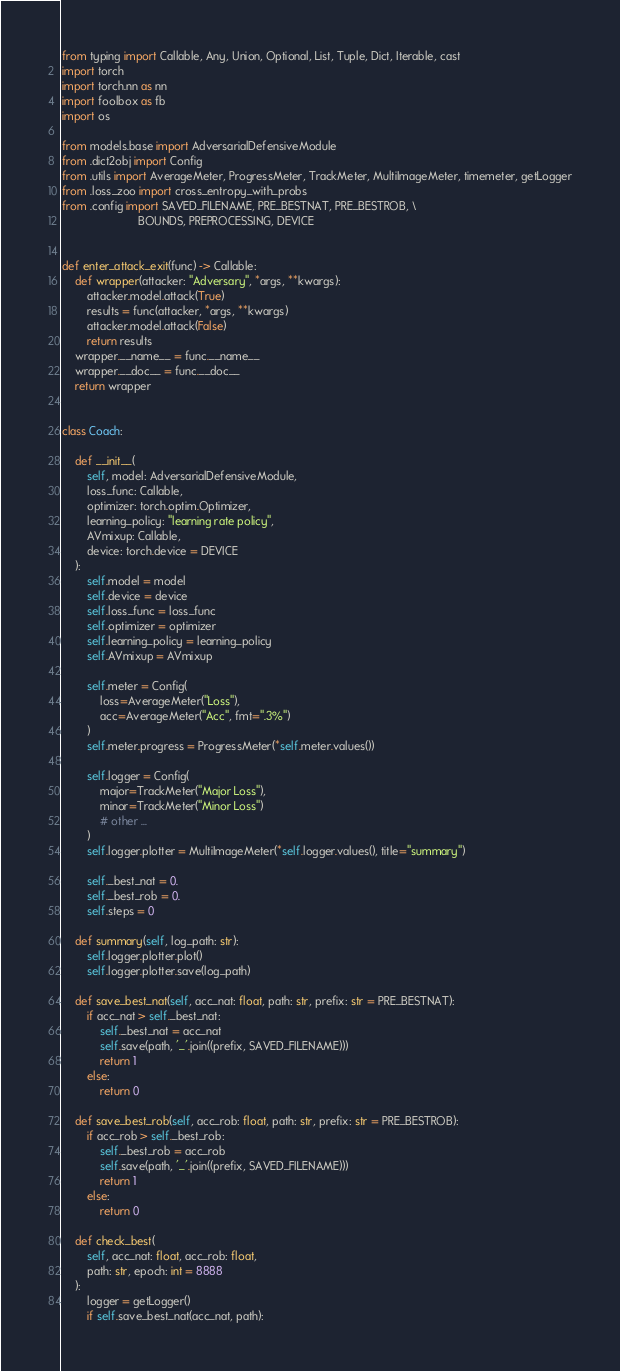<code> <loc_0><loc_0><loc_500><loc_500><_Python_>


from typing import Callable, Any, Union, Optional, List, Tuple, Dict, Iterable, cast
import torch
import torch.nn as nn
import foolbox as fb
import os

from models.base import AdversarialDefensiveModule
from .dict2obj import Config
from .utils import AverageMeter, ProgressMeter, TrackMeter, MultiImageMeter, timemeter, getLogger
from .loss_zoo import cross_entropy_with_probs
from .config import SAVED_FILENAME, PRE_BESTNAT, PRE_BESTROB, \
                        BOUNDS, PREPROCESSING, DEVICE


def enter_attack_exit(func) -> Callable:
    def wrapper(attacker: "Adversary", *args, **kwargs):
        attacker.model.attack(True)
        results = func(attacker, *args, **kwargs)
        attacker.model.attack(False)
        return results
    wrapper.__name__ = func.__name__
    wrapper.__doc__ = func.__doc__
    return wrapper


class Coach:
    
    def __init__(
        self, model: AdversarialDefensiveModule,
        loss_func: Callable, 
        optimizer: torch.optim.Optimizer, 
        learning_policy: "learning rate policy",
        AVmixup: Callable,
        device: torch.device = DEVICE
    ):
        self.model = model
        self.device = device
        self.loss_func = loss_func
        self.optimizer = optimizer
        self.learning_policy = learning_policy
        self.AVmixup = AVmixup

        self.meter = Config(
            loss=AverageMeter("Loss"),
            acc=AverageMeter("Acc", fmt=".3%")
        )
        self.meter.progress = ProgressMeter(*self.meter.values())

        self.logger = Config(
            major=TrackMeter("Major Loss"),
            minor=TrackMeter("Minor Loss")
            # other ...
        )
        self.logger.plotter = MultiImageMeter(*self.logger.values(), title="summary")

        self._best_nat = 0.
        self._best_rob = 0.
        self.steps = 0

    def summary(self, log_path: str):
        self.logger.plotter.plot()
        self.logger.plotter.save(log_path)

    def save_best_nat(self, acc_nat: float, path: str, prefix: str = PRE_BESTNAT):
        if acc_nat > self._best_nat:
            self._best_nat = acc_nat
            self.save(path, '_'.join((prefix, SAVED_FILENAME)))
            return 1
        else:
            return 0
    
    def save_best_rob(self, acc_rob: float, path: str, prefix: str = PRE_BESTROB):
        if acc_rob > self._best_rob:
            self._best_rob = acc_rob
            self.save(path, '_'.join((prefix, SAVED_FILENAME)))
            return 1
        else:
            return 0

    def check_best(
        self, acc_nat: float, acc_rob: float,
        path: str, epoch: int = 8888
    ):
        logger = getLogger()
        if self.save_best_nat(acc_nat, path):</code> 